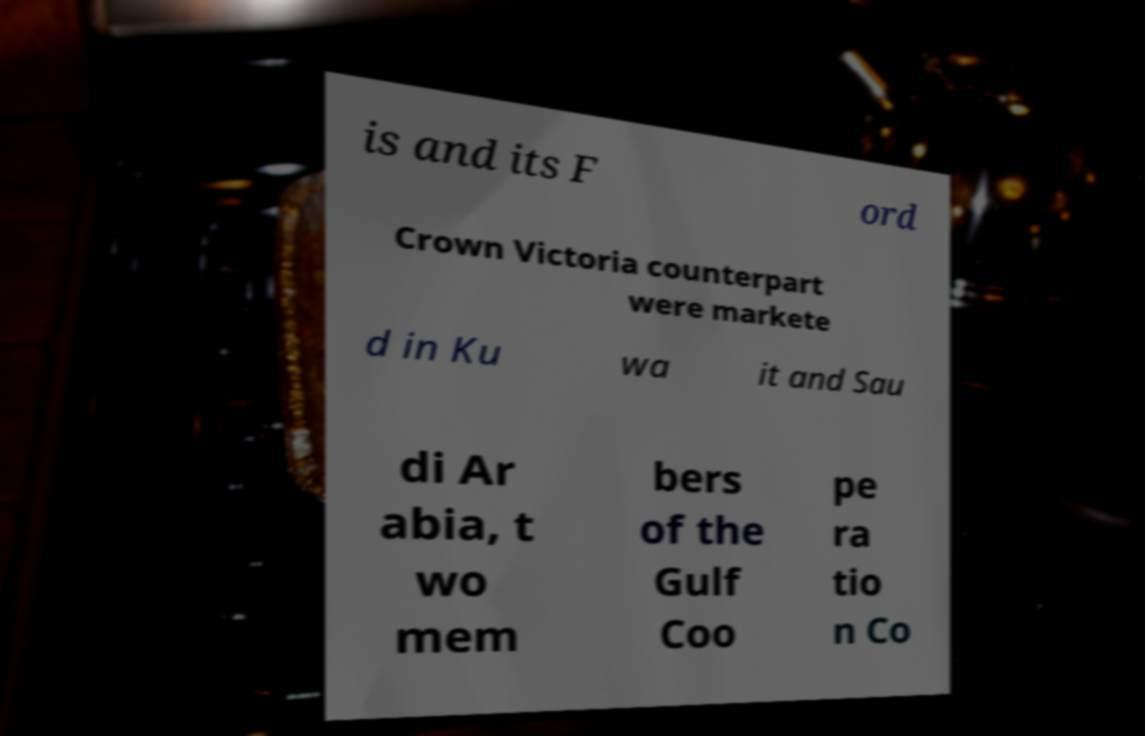I need the written content from this picture converted into text. Can you do that? is and its F ord Crown Victoria counterpart were markete d in Ku wa it and Sau di Ar abia, t wo mem bers of the Gulf Coo pe ra tio n Co 